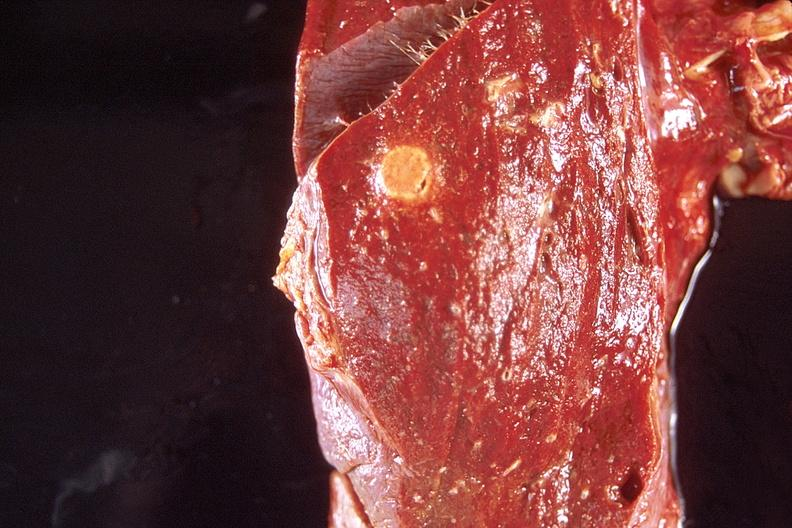what is present?
Answer the question using a single word or phrase. Respiratory 